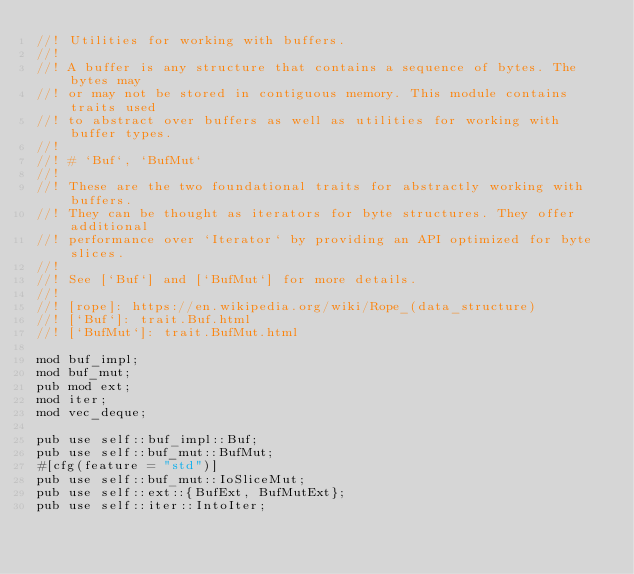<code> <loc_0><loc_0><loc_500><loc_500><_Rust_>//! Utilities for working with buffers.
//!
//! A buffer is any structure that contains a sequence of bytes. The bytes may
//! or may not be stored in contiguous memory. This module contains traits used
//! to abstract over buffers as well as utilities for working with buffer types.
//!
//! # `Buf`, `BufMut`
//!
//! These are the two foundational traits for abstractly working with buffers.
//! They can be thought as iterators for byte structures. They offer additional
//! performance over `Iterator` by providing an API optimized for byte slices.
//!
//! See [`Buf`] and [`BufMut`] for more details.
//!
//! [rope]: https://en.wikipedia.org/wiki/Rope_(data_structure)
//! [`Buf`]: trait.Buf.html
//! [`BufMut`]: trait.BufMut.html

mod buf_impl;
mod buf_mut;
pub mod ext;
mod iter;
mod vec_deque;

pub use self::buf_impl::Buf;
pub use self::buf_mut::BufMut;
#[cfg(feature = "std")]
pub use self::buf_mut::IoSliceMut;
pub use self::ext::{BufExt, BufMutExt};
pub use self::iter::IntoIter;
</code> 